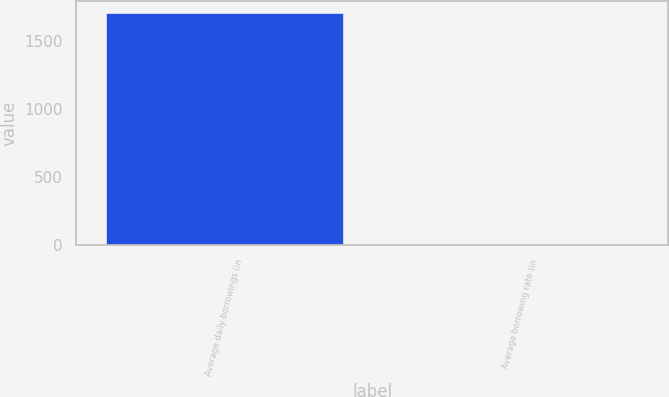Convert chart to OTSL. <chart><loc_0><loc_0><loc_500><loc_500><bar_chart><fcel>Average daily borrowings (in<fcel>Average borrowing rate (in<nl><fcel>1711<fcel>5.9<nl></chart> 